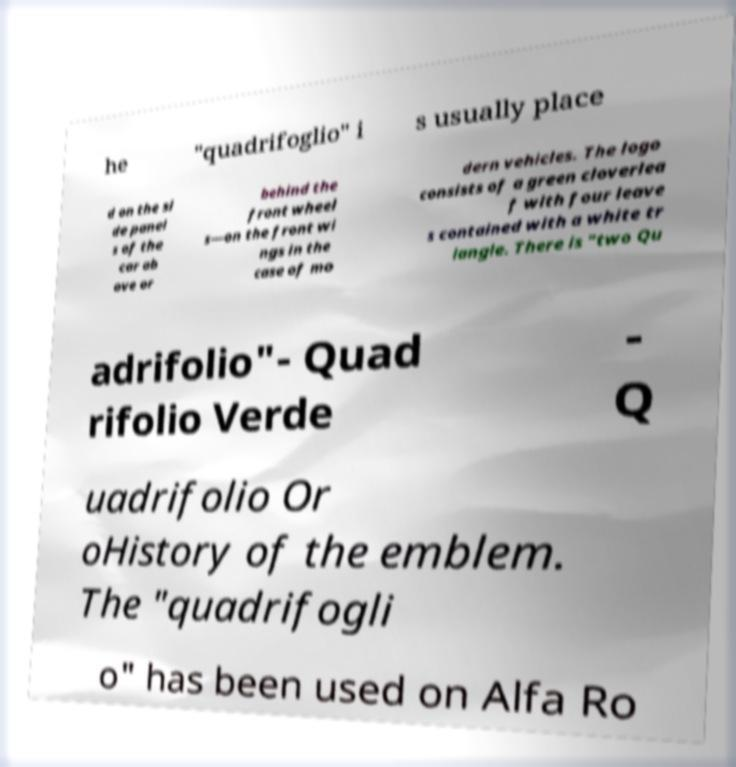What messages or text are displayed in this image? I need them in a readable, typed format. he "quadrifoglio" i s usually place d on the si de panel s of the car ab ove or behind the front wheel s—on the front wi ngs in the case of mo dern vehicles. The logo consists of a green cloverlea f with four leave s contained with a white tr iangle. There is "two Qu adrifolio"- Quad rifolio Verde - Q uadrifolio Or oHistory of the emblem. The "quadrifogli o" has been used on Alfa Ro 